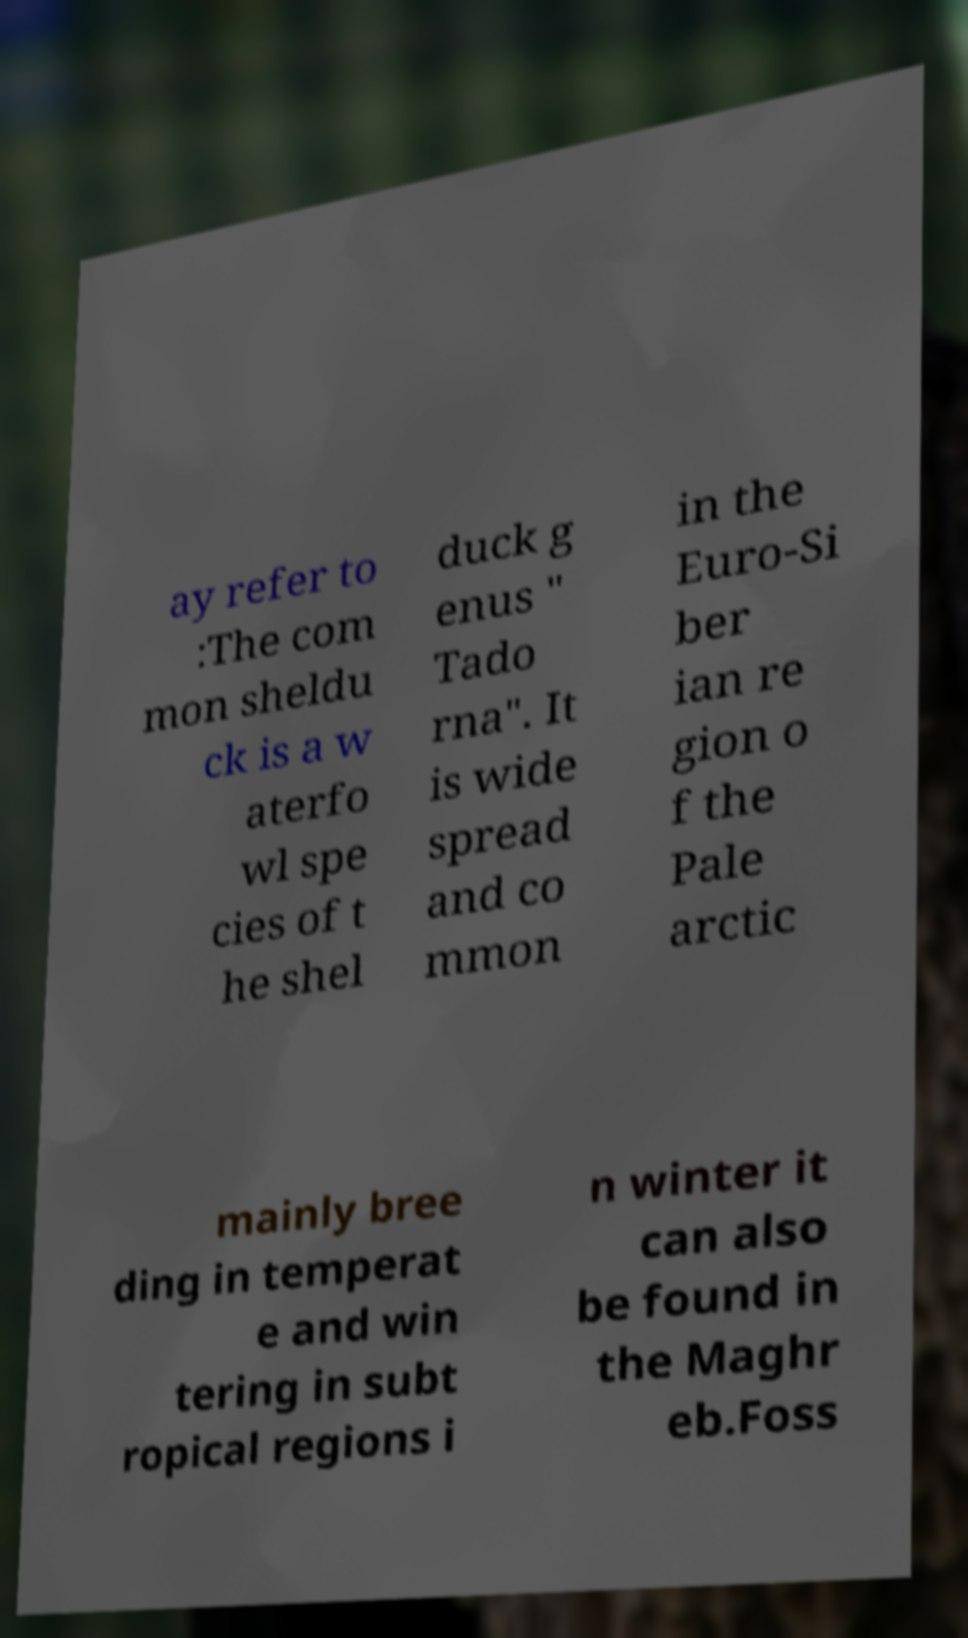Can you read and provide the text displayed in the image?This photo seems to have some interesting text. Can you extract and type it out for me? ay refer to :The com mon sheldu ck is a w aterfo wl spe cies of t he shel duck g enus " Tado rna". It is wide spread and co mmon in the Euro-Si ber ian re gion o f the Pale arctic mainly bree ding in temperat e and win tering in subt ropical regions i n winter it can also be found in the Maghr eb.Foss 